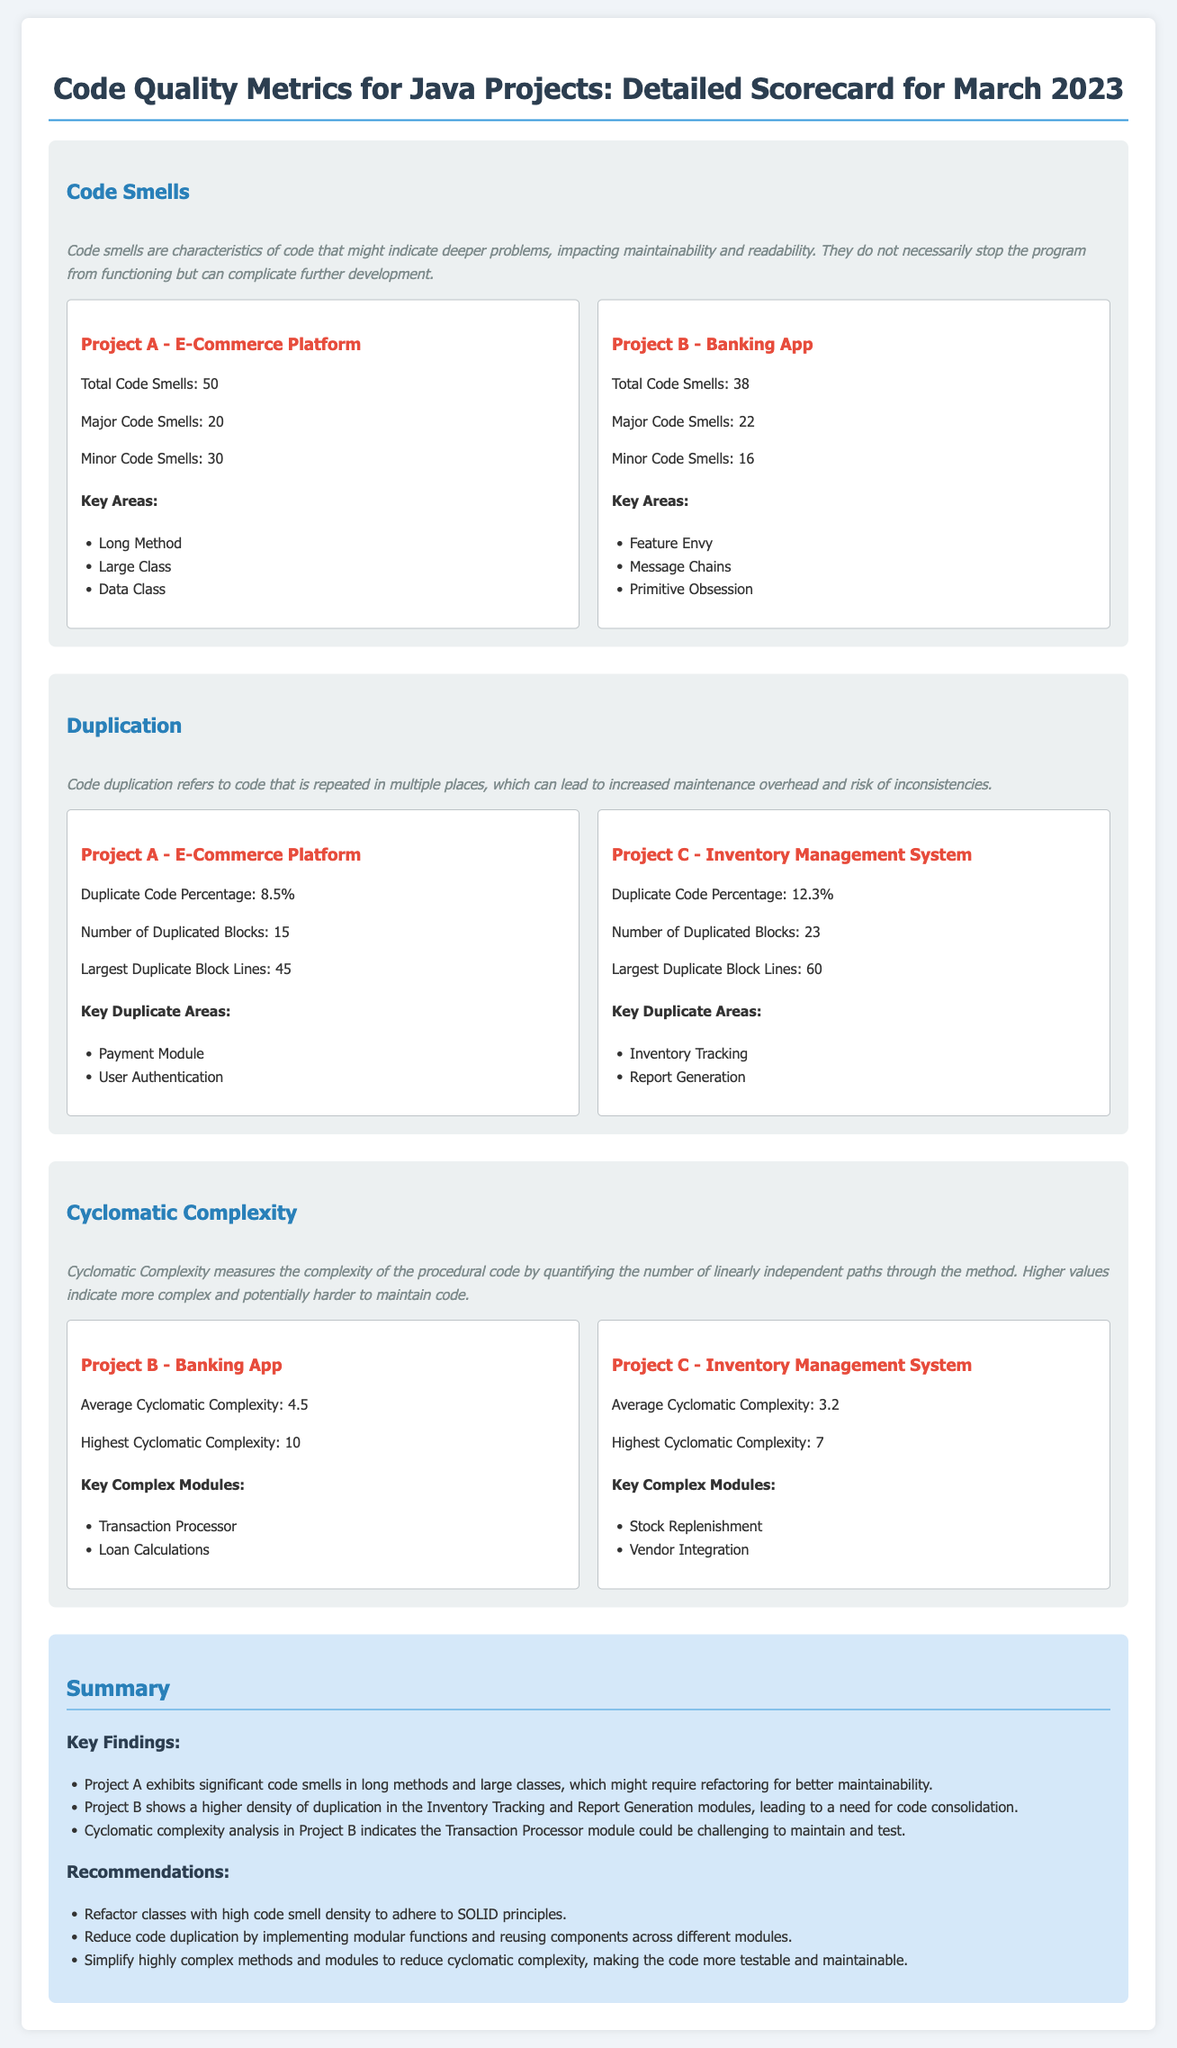What is the total number of code smells in Project A? Project A has 50 total code smells as stated in the document.
Answer: 50 What is the highest cyclomatic complexity in Project B? The document indicates that the highest cyclomatic complexity in Project B is 10.
Answer: 10 What percentage of duplicate code is found in Project C? The document reports that Project C has a duplicate code percentage of 12.3%.
Answer: 12.3% Which project has the most major code smells? Project B has 22 major code smells, which is more than Project A's 20 major code smells.
Answer: Project B What is the primary key area of code smells in Project A? The document lists "Long Method" as a key area of code smells for Project A.
Answer: Long Method Which project shows a need for modular functions to reduce duplication? The document suggests Project B shows a higher density of duplication, indicating a need for modular functions.
Answer: Project B What key recommendation is made for simplifying complex methods? The recommendation is to simplify highly complex methods and modules to reduce cyclomatic complexity.
Answer: Simplify methods How many duplicated blocks are identified in Project A? The document states that Project A has 15 duplicated blocks.
Answer: 15 What is the average cyclomatic complexity of Project C? The average cyclomatic complexity of Project C is reported as 3.2 in the document.
Answer: 3.2 